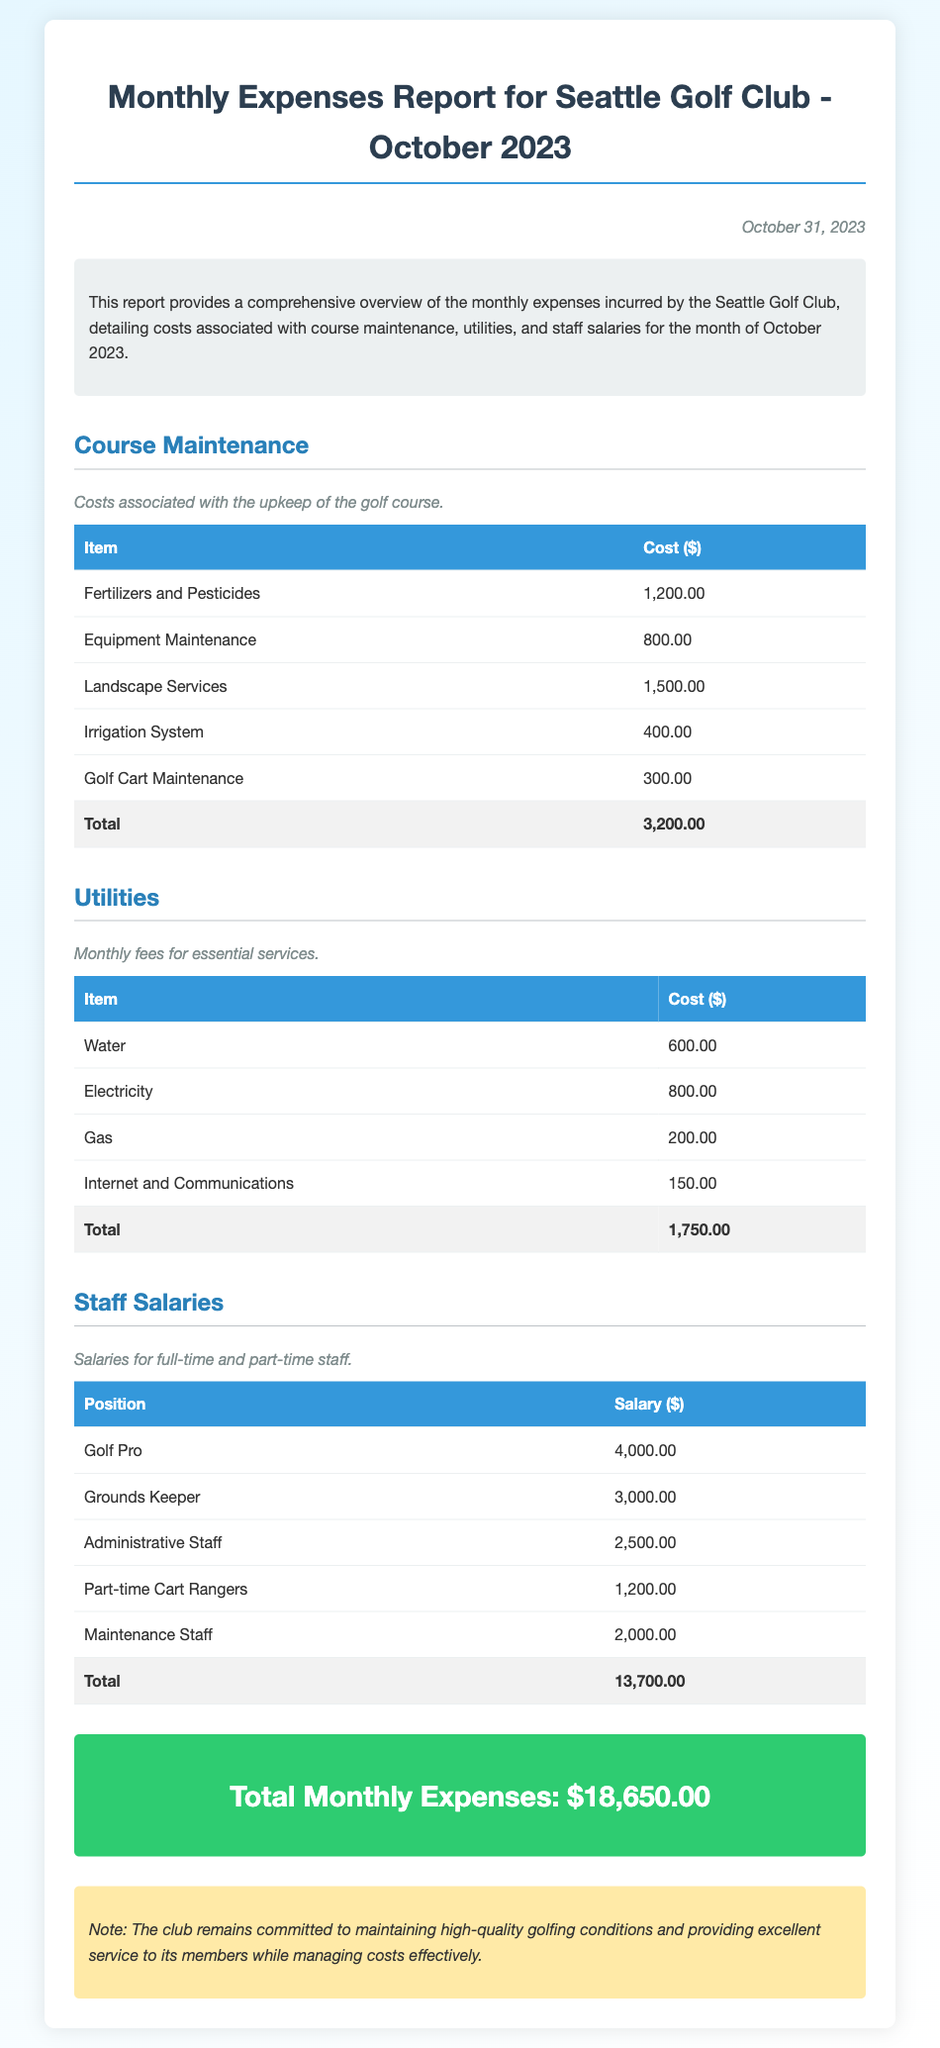What is the total cost for Course Maintenance? The total cost for Course Maintenance is listed at the bottom of the section detailing the expenses.
Answer: 3,200.00 How much was spent on Electricity? The cost of Electricity is specified in the Utilities section, demonstrating its contribution to overall expenses.
Answer: 800.00 What is the total salary for Staff Salaries? The total salary is the last figure in the Staff Salaries section providing a summary of all salaries combined.
Answer: 13,700.00 What was the total monthly expense for October 2023? The total monthly expense is clearly stated at the end of the report providing a summary of all categories.
Answer: 18,650.00 What is the cost for Water? The Water expense is listed in the Utilities section, highlighting its cost as part of monthly utilities.
Answer: 600.00 How much was spent on Golf Cart Maintenance? Golf Cart Maintenance expense is an individual line item under Course Maintenance detailing its specific cost.
Answer: 300.00 How many categories of expenses are there in this report? The report is structured into specific sections, and the number of expense categories can be counted from the document structure.
Answer: 3 What is the cost description for Fertilizers and Pesticides? The description explains the nature of the expense related to course upkeep specifically for fertilizers and pesticides.
Answer: Costs associated with the upkeep of the golf course 